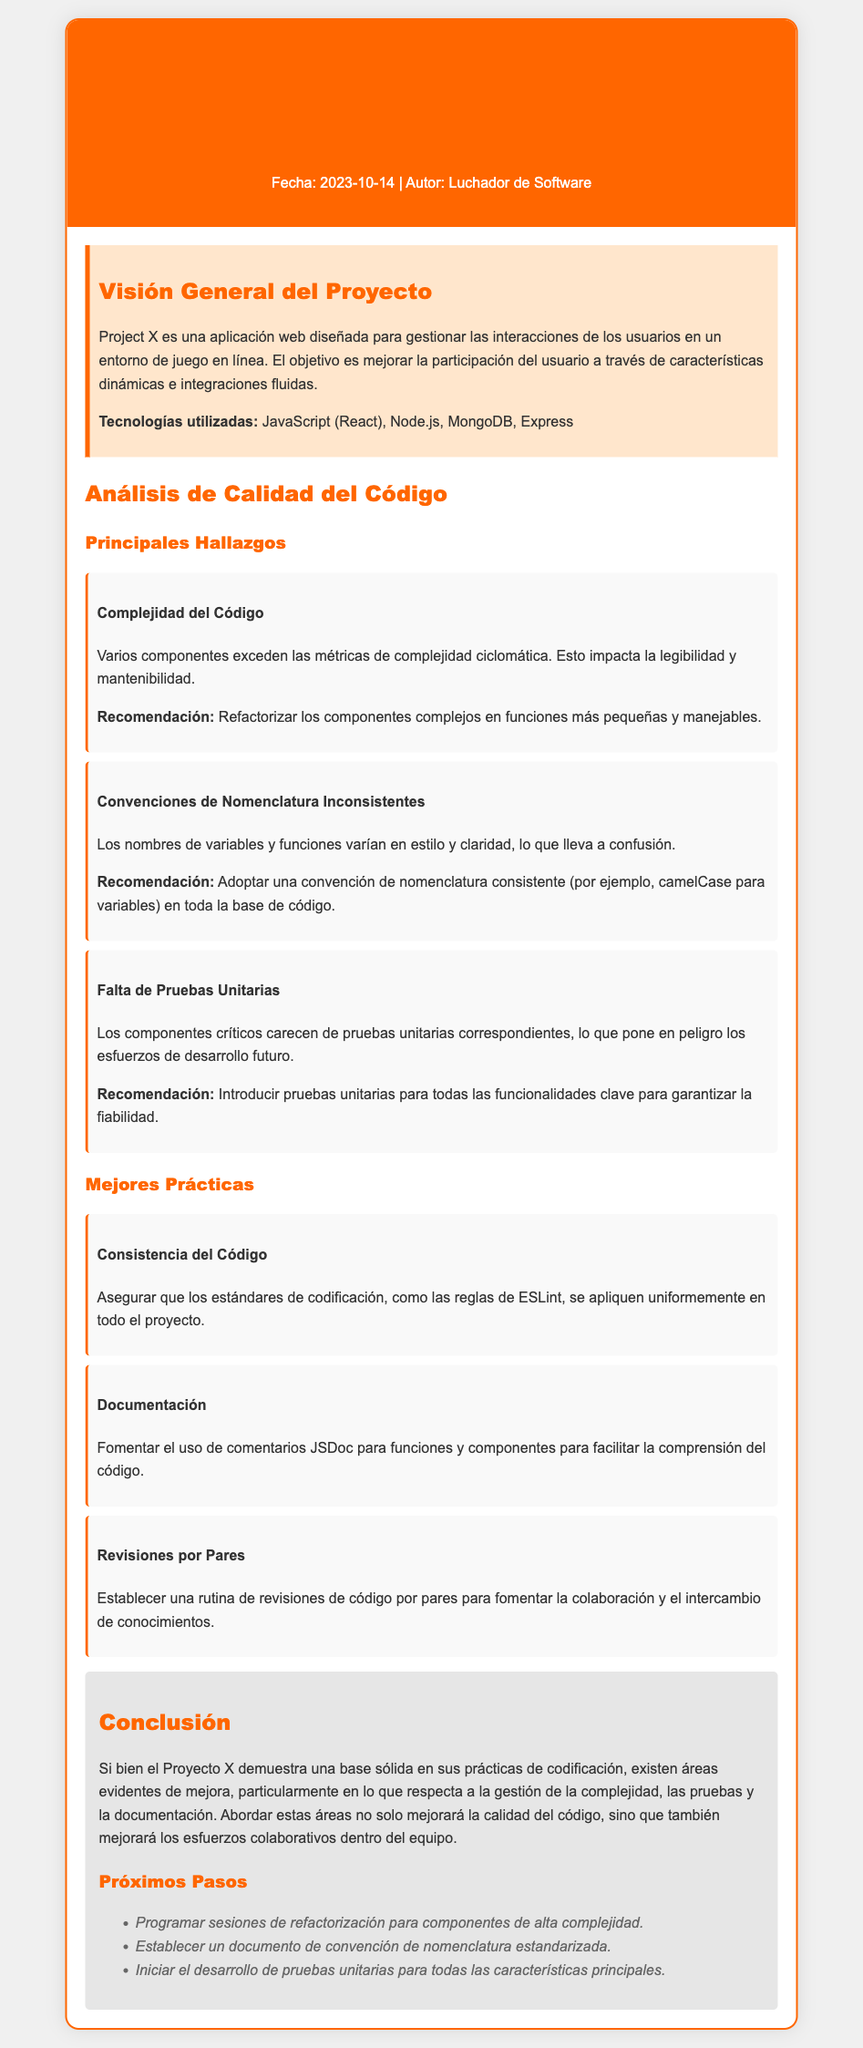¿Qué es Project X? Project X es una aplicación web diseñada para gestionar las interacciones de los usuarios en un entorno de juego en línea.
Answer: una aplicación web ¿Cuál es la fecha de la revisión de código? La fecha de la revisión de código se encuentra en el encabezado del documento, que es 2023-10-14.
Answer: 2023-10-14 ¿Qué tecnología se utiliza para el backend de Project X? La tecnología usada para el backend, indicada en la visión general del proyecto, es Node.js.
Answer: Node.js ¿Cuál es un hallazgo sobre la complejidad del código? Se menciona que varios componentes exceden las métricas de complejidad ciclomática.
Answer: complejidad ciclomática ¿Qué recomendación se da para la falta de pruebas unitarias? La recomendación es introducir pruebas unitarias para todas las funcionalidades clave.
Answer: Introducir pruebas unitarias ¿Cuál es una mejor práctica recomendada en el documento? Se sugiere asegurar que los estándares de codificación se apliquen uniformemente en todo el proyecto.
Answer: Consistencia del Código ¿Cuál es el objetivo principal del Proyecto X? El objetivo es mejorar la participación del usuario a través de características dinámicas e integraciones fluidas.
Answer: mejorar la participación del usuario ¿Qué acción se sugiere como próximo paso relacionado con la refactorización? Se sugiere programar sesiones de refactorización para componentes de alta complejidad.
Answer: Programar sesiones de refactorización 